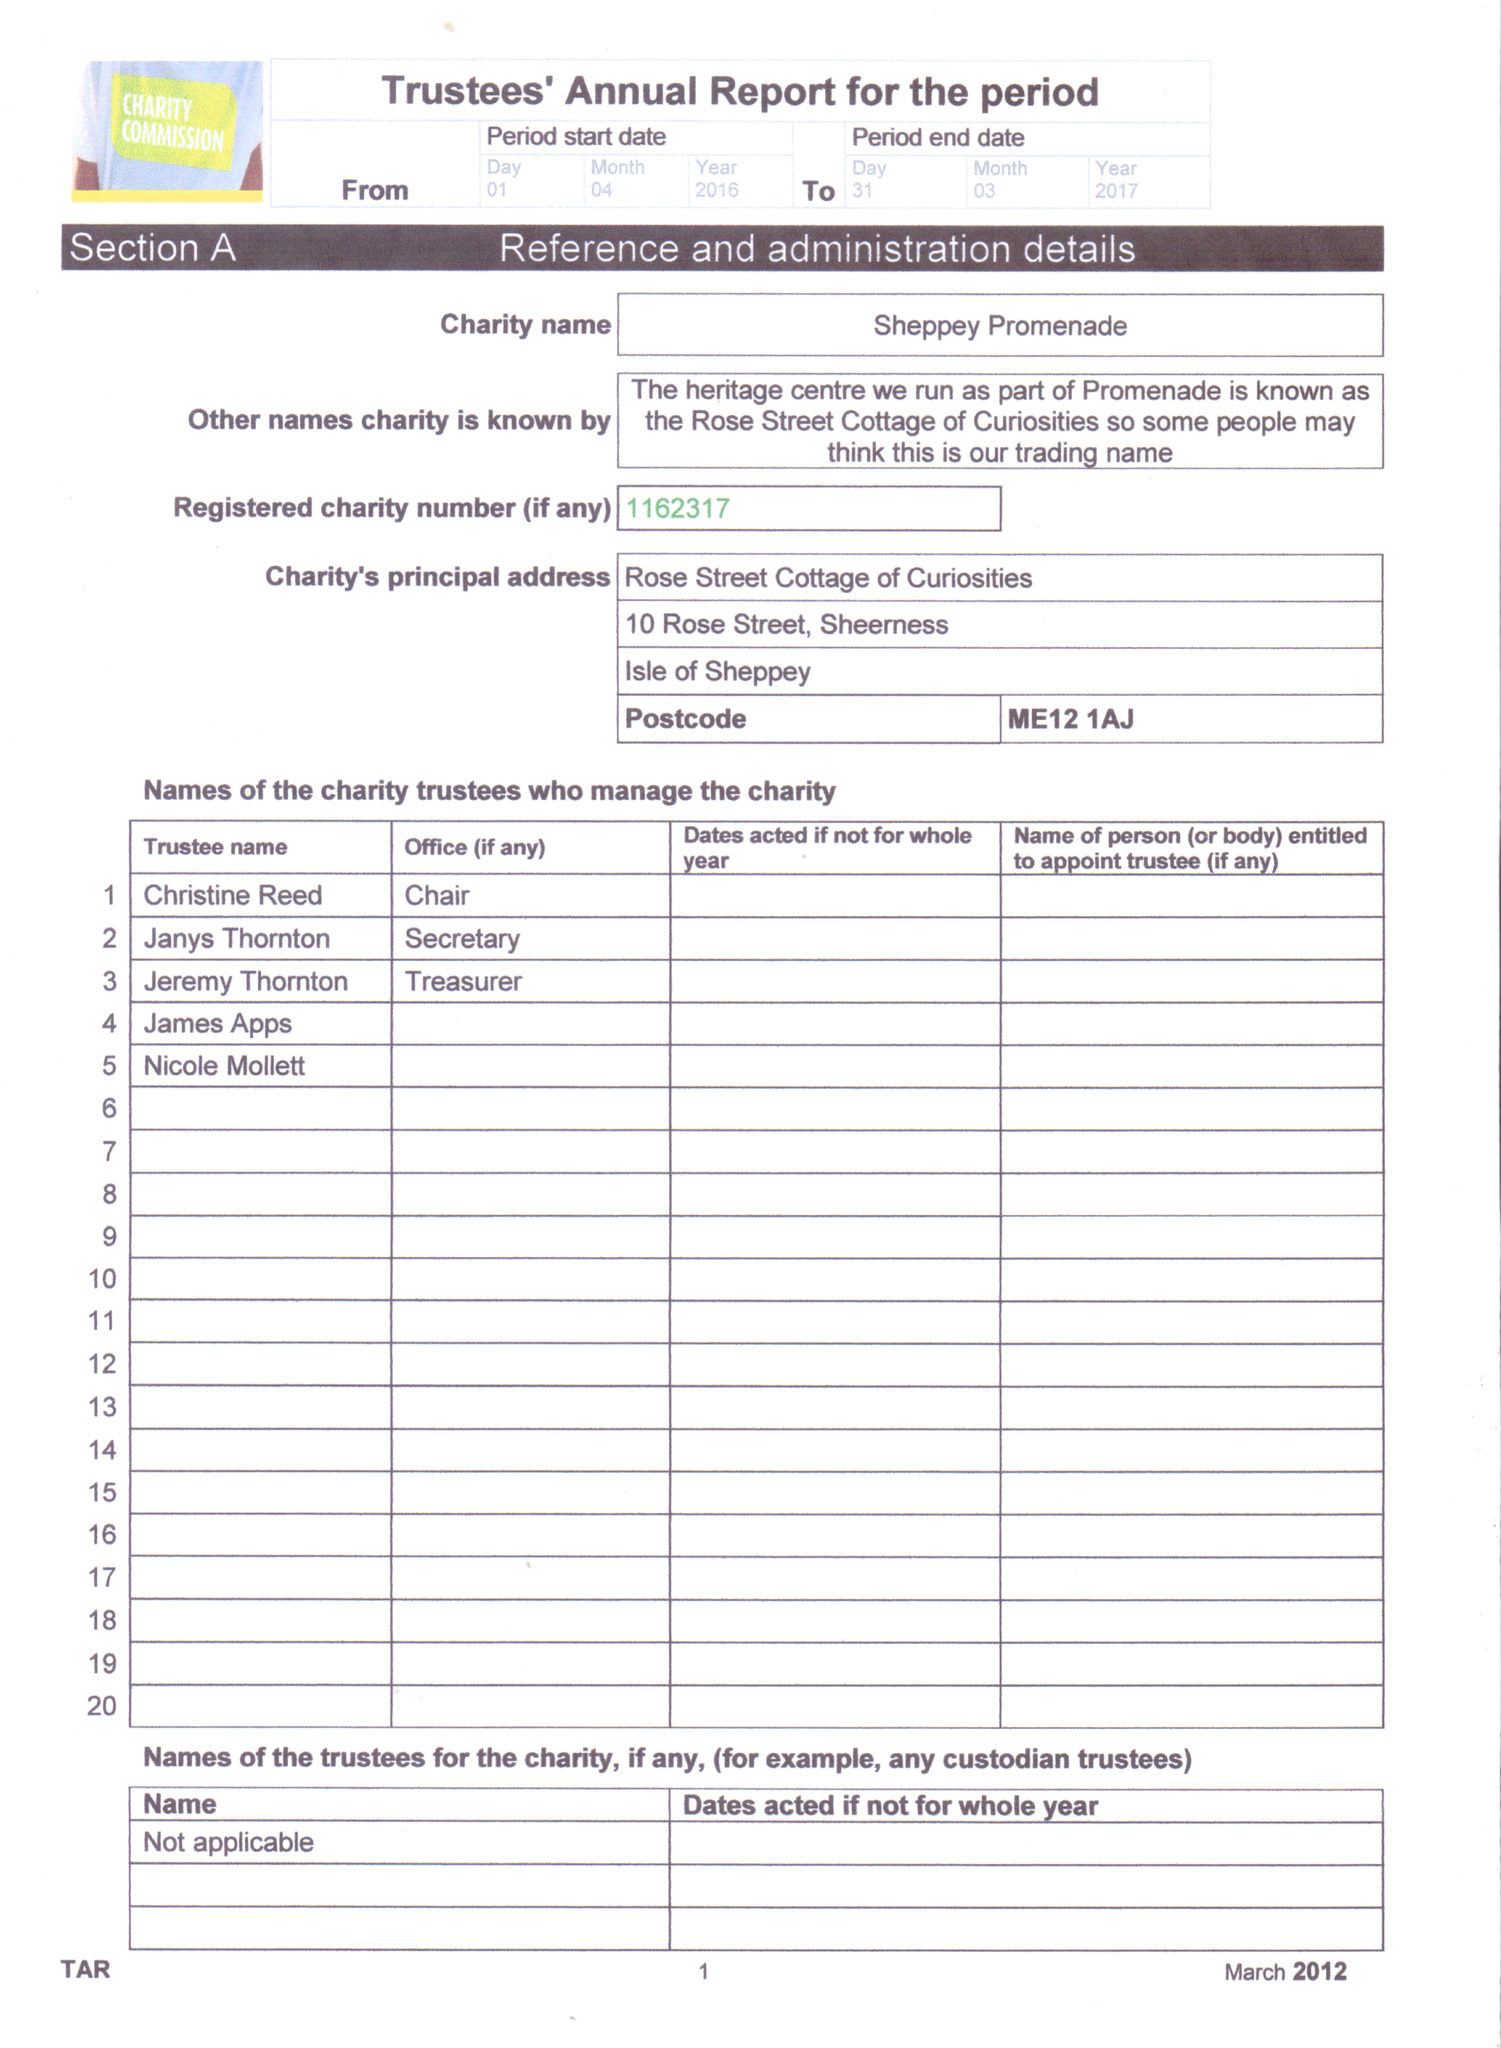What is the value for the report_date?
Answer the question using a single word or phrase. 2017-03-31 